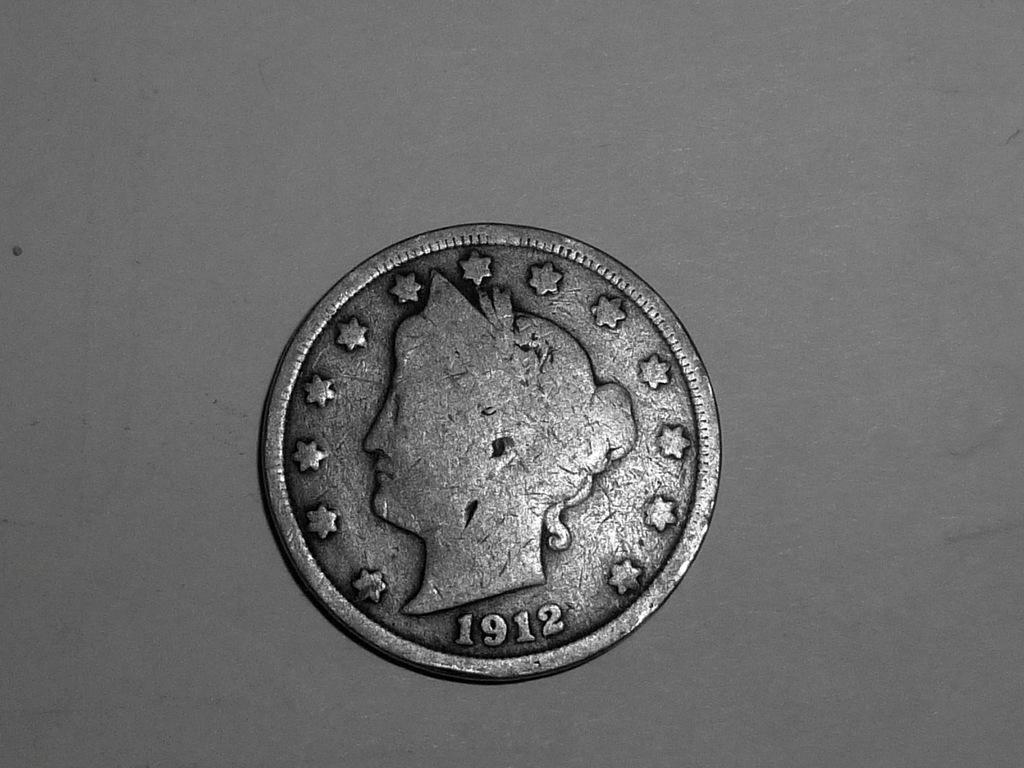<image>
Describe the image concisely. A silver coin made in 1912 with a woman's head on it 